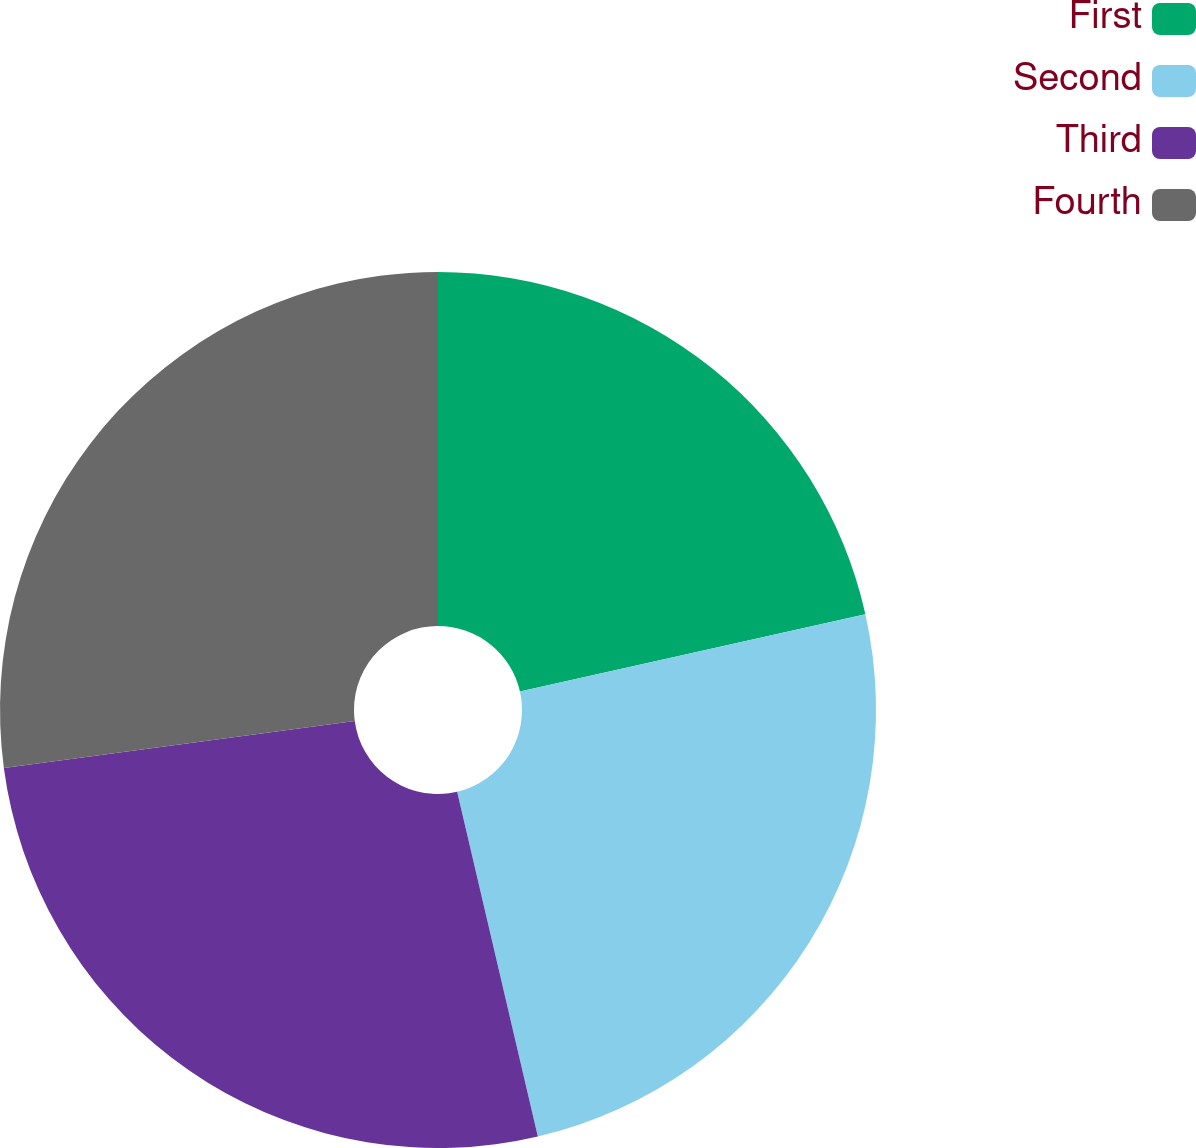Convert chart to OTSL. <chart><loc_0><loc_0><loc_500><loc_500><pie_chart><fcel>First<fcel>Second<fcel>Third<fcel>Fourth<nl><fcel>21.49%<fcel>24.85%<fcel>26.55%<fcel>27.11%<nl></chart> 